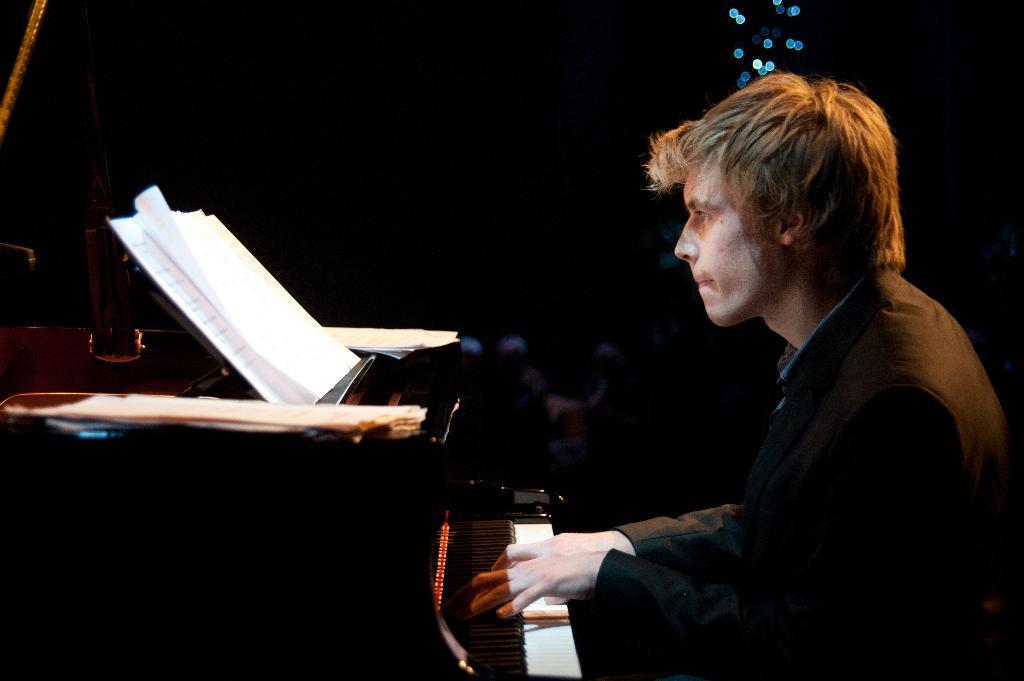Describe this image in one or two sentences. Here we can see a person playing piano with musical notes present in front of him 